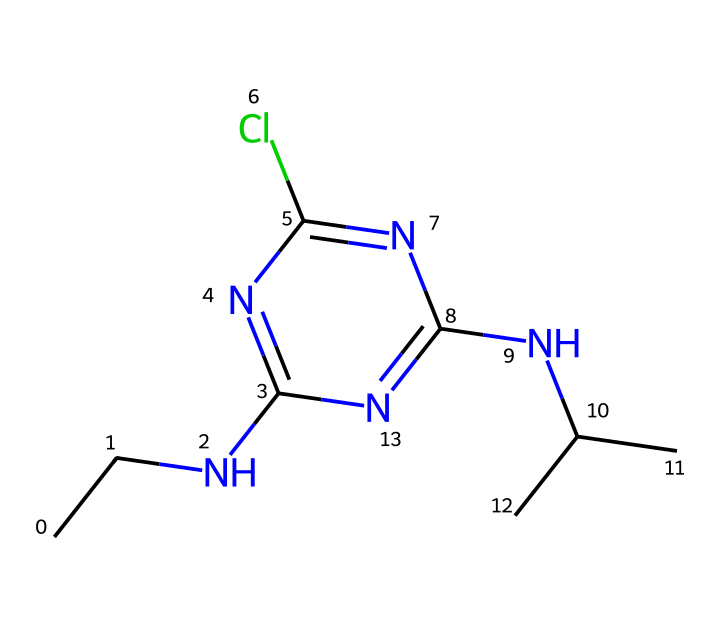what is the chemical name of this compound? The SMILES structure corresponds to a chemical named atrazine, which is a well-known herbicide recognized for its applications in agriculture. The name is derived from its systematic representation and known associations in the field of chemistry.
Answer: atrazine how many nitrogen atoms are present in this structure? By analyzing the SMILES representation, there are four nitrogen atoms visible in the structure, indicated by 'N' in the notation. Counting each 'N' provides the total for the molecule.
Answer: four what is the molecular formula based on the SMILES representation? From the SMILES notation, the total number of carbon (C), hydrogen (H), chlorine (Cl), and nitrogen (N) atoms can be counted: 8 carbons, 14 hydrogens, 4 nitrogens, and 1 chlorine. This gives the formula C8H14ClN5.
Answer: C8H14ClN5 how does the presence of chlorine affect the herbicide properties? The chlorine atom in the structure often enhances the herbicide's efficacy by altering its lipophilicity, allowing it to better penetrate plant tissues. Additionally, chlorine can affect the chemical's stability and persistence in the environment.
Answer: enhances efficacy how might atrazine's molecular structure lead to contamination of water sources? Atrazine, with its stable and persistent molecular structure, can leach into groundwater during rainfall or through runoff, as its properties allow it to remain intact in the environment. This characteristic makes it a concern for water quality where astronomical facilities are located.
Answer: leaching what role do tertiary amines, indicated by the structure, play in atrazine's function? The presence of tertiary amines in the structure contributes to the herbicide's mechanism by affecting its interaction with the target enzyme systems in plants, which are critical for growth and development. Understanding this interaction is essential in assessing its efficacy as a herbicide.
Answer: interact with enzymes 